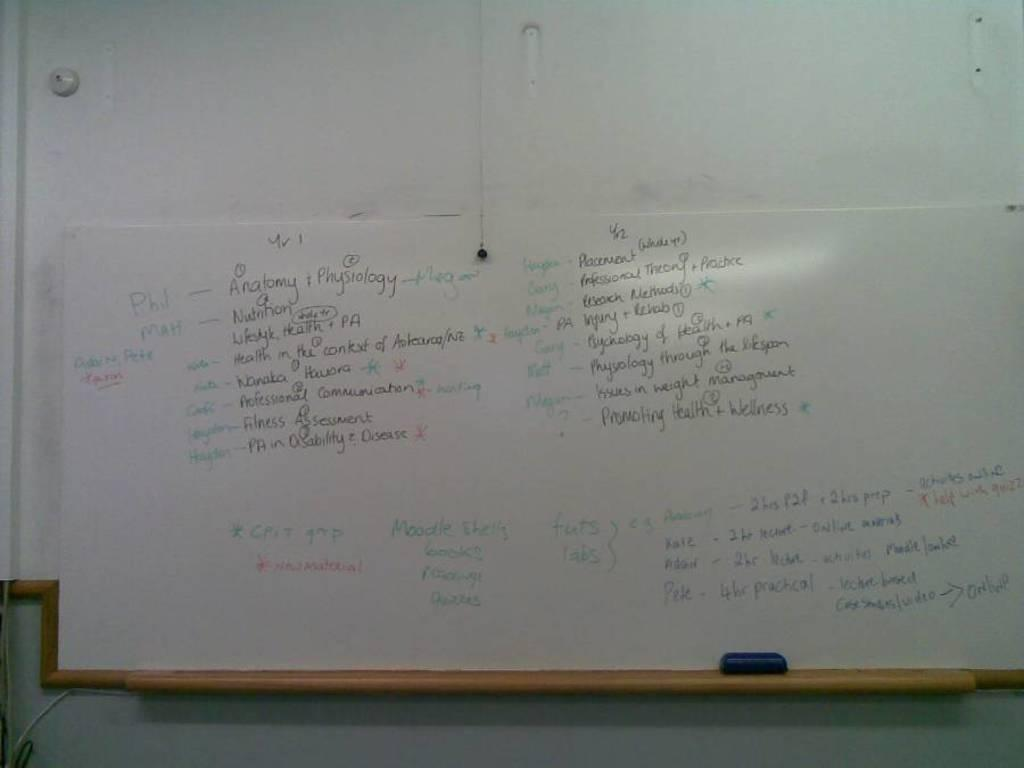Provide a one-sentence caption for the provided image. A marker board reads that Phil and Megan will be responsible for Anatomy and Physiology. 